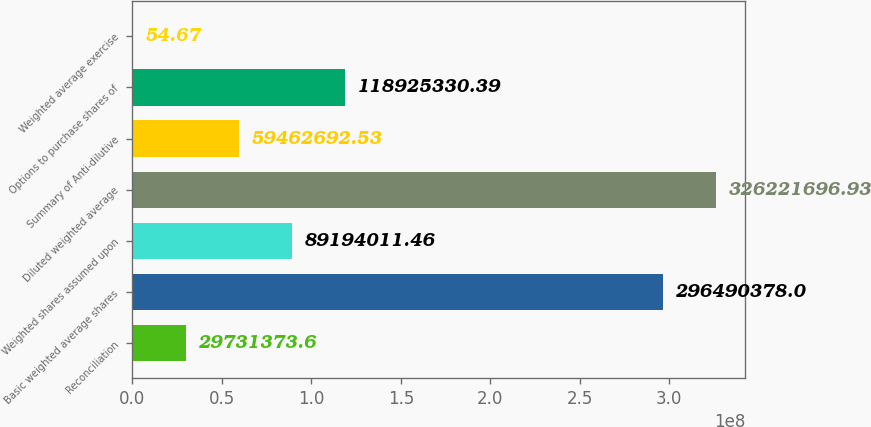<chart> <loc_0><loc_0><loc_500><loc_500><bar_chart><fcel>Reconciliation<fcel>Basic weighted average shares<fcel>Weighted shares assumed upon<fcel>Diluted weighted average<fcel>Summary of Anti-dilutive<fcel>Options to purchase shares of<fcel>Weighted average exercise<nl><fcel>2.97314e+07<fcel>2.9649e+08<fcel>8.9194e+07<fcel>3.26222e+08<fcel>5.94627e+07<fcel>1.18925e+08<fcel>54.67<nl></chart> 